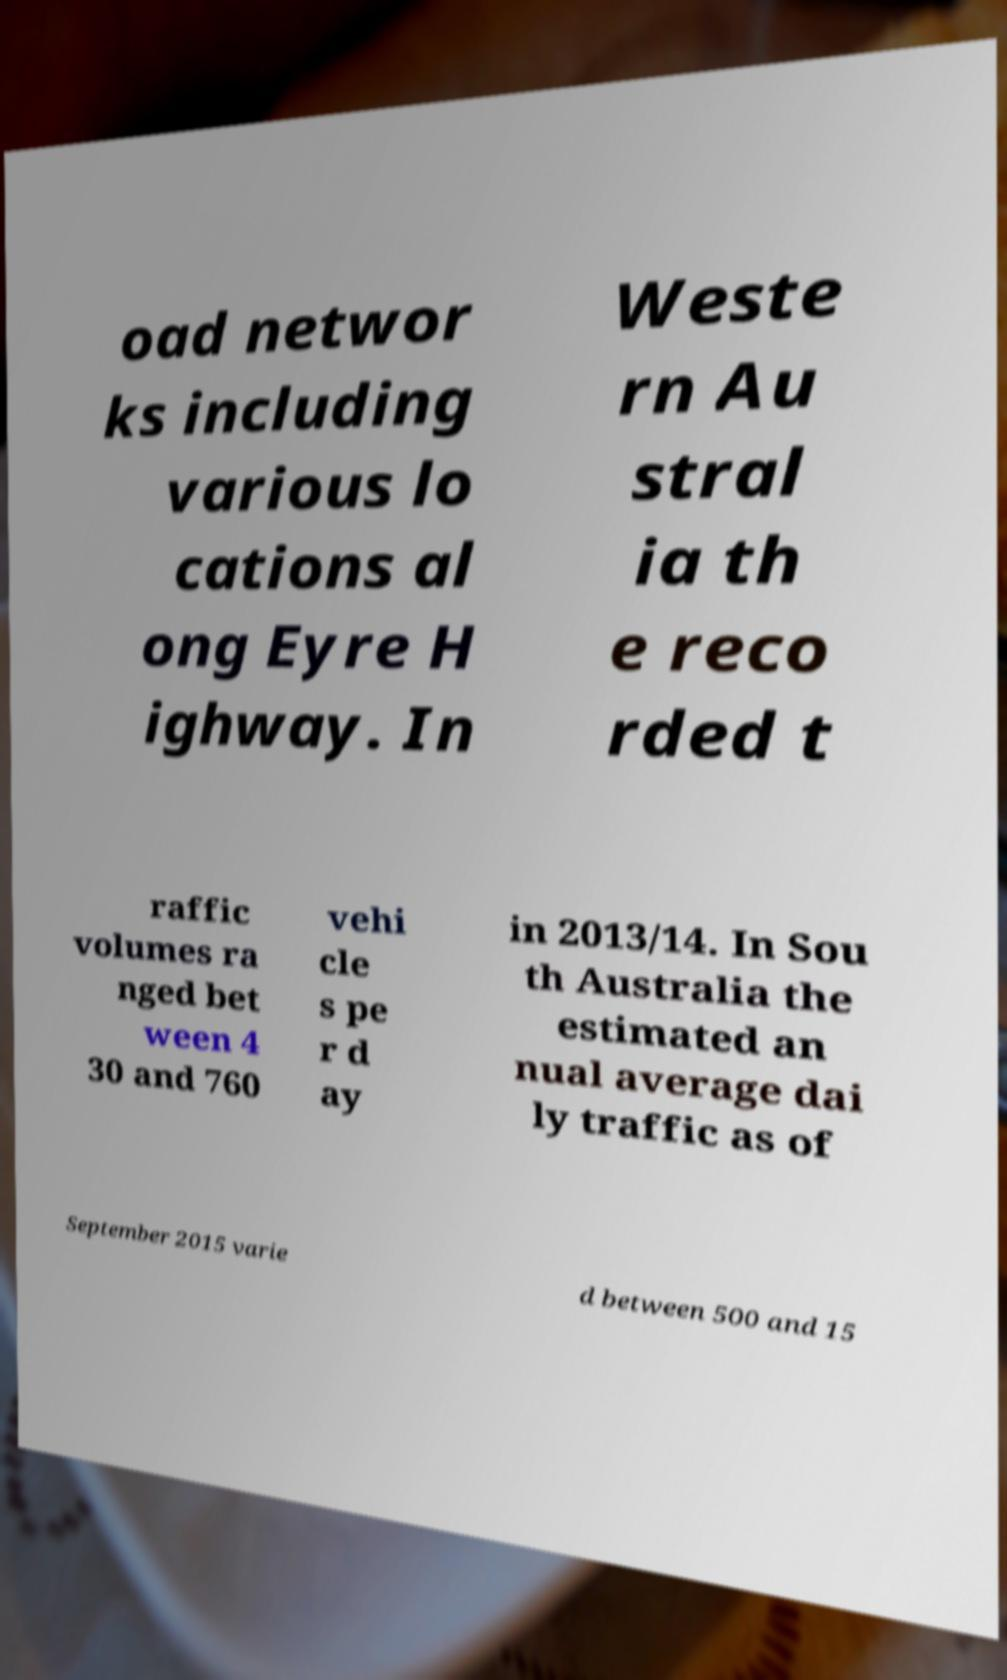Could you assist in decoding the text presented in this image and type it out clearly? oad networ ks including various lo cations al ong Eyre H ighway. In Weste rn Au stral ia th e reco rded t raffic volumes ra nged bet ween 4 30 and 760 vehi cle s pe r d ay in 2013/14. In Sou th Australia the estimated an nual average dai ly traffic as of September 2015 varie d between 500 and 15 